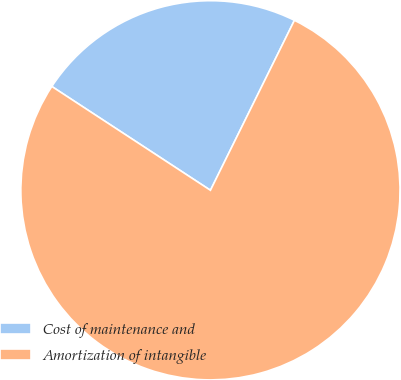Convert chart. <chart><loc_0><loc_0><loc_500><loc_500><pie_chart><fcel>Cost of maintenance and<fcel>Amortization of intangible<nl><fcel>23.08%<fcel>76.92%<nl></chart> 